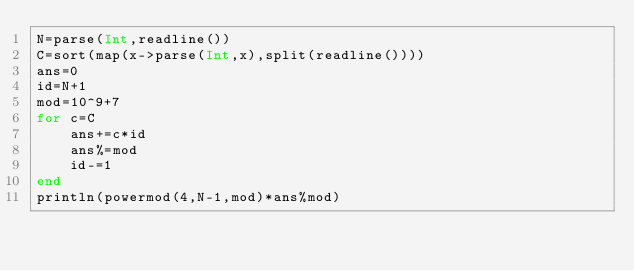Convert code to text. <code><loc_0><loc_0><loc_500><loc_500><_Julia_>N=parse(Int,readline())
C=sort(map(x->parse(Int,x),split(readline())))
ans=0
id=N+1
mod=10^9+7
for c=C
	ans+=c*id
	ans%=mod
	id-=1
end
println(powermod(4,N-1,mod)*ans%mod)</code> 